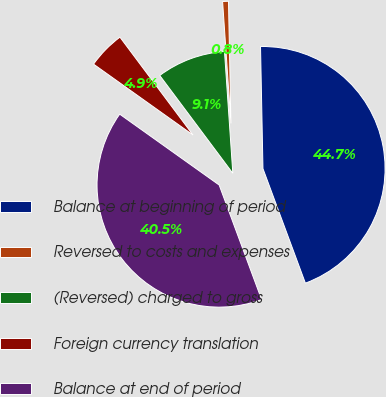Convert chart. <chart><loc_0><loc_0><loc_500><loc_500><pie_chart><fcel>Balance at beginning of period<fcel>Reversed to costs and expenses<fcel>(Reversed) charged to gross<fcel>Foreign currency translation<fcel>Balance at end of period<nl><fcel>44.67%<fcel>0.77%<fcel>9.12%<fcel>4.94%<fcel>40.5%<nl></chart> 